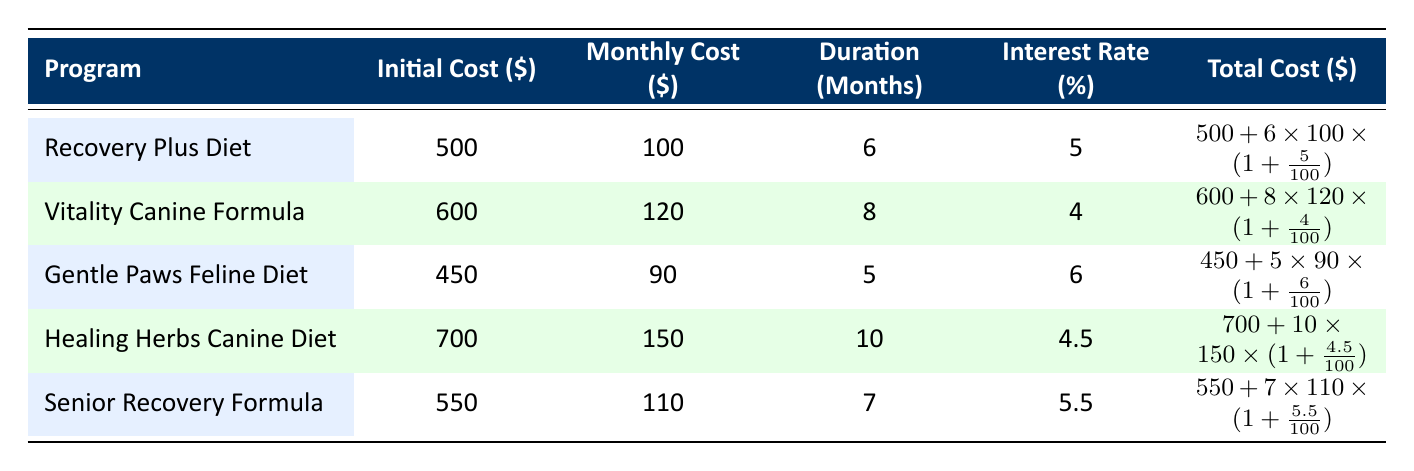What is the total initial cost for the Recovery Plus Diet? The initial cost for the Recovery Plus Diet is listed directly in the table, which shows it as 500.
Answer: 500 What is the monthly cost of the Healing Herbs Canine Diet? The monthly cost for the Healing Herbs Canine Diet is clearly stated in the table as 150.
Answer: 150 Which program has the highest interest rate? By comparing the interest rates listed for each program, the Gentle Paws Feline Diet has the highest interest rate at 6%.
Answer: Gentle Paws Feline Diet What is the total cost for the Vitality Canine Formula? To find the total cost, we calculate: initial cost 600 plus (monthly cost 120 times duration 8 months) plus interest, which results in 600 + (120 * 8) * (1 + 0.04) = 600 + 960 * 1.04 = 600 + 998.4 = 1598.4.
Answer: 1598.4 Is the duration of the Senior Recovery Formula longer than the duration of the Recovery Plus Diet? The duration for the Senior Recovery Formula is 7 months while the Recovery Plus Diet is 6 months. Since 7 is greater than 6, the statement is true.
Answer: Yes What is the average monthly cost across all specialized diet programs? To find the average monthly cost, sum all the monthly costs (100 + 120 + 90 + 150 + 110 = 570) and divide by the number of programs (5), which results in 570 / 5 = 114.
Answer: 114 Which specialized diet program costs the least in terms of initial cost? By comparing initial costs, the Gentle Paws Feline Diet has the lowest initial cost at 450.
Answer: Gentle Paws Feline Diet Is the total cost for the Healing Herbs Canine Diet greater than 2000? The total cost calculation shows: initial cost 700 plus (monthly cost 150 times duration 10 months) plus interest, resulting in 700 + (150 * 10) * (1 + 0.045) = 700 + 1500 * 1.045 = 700 + 1567.5 = 2267.5, which is greater than 2000.
Answer: Yes What is the difference in total cost between the Recovery Plus Diet and the Gentle Paws Feline Diet? Total cost for Recovery Plus is calculated as 500 + (100 * 6) * (1 + 0.05) = 500 + 600 * 1.05 = 500 + 630 = 1130. Total cost for Gentle Paws is 450 + (90 * 5) * (1 + 0.06) = 450 + 450 * 1.06 = 450 + 477 = 927. The difference in total costs is 1130 - 927 = 203.
Answer: 203 